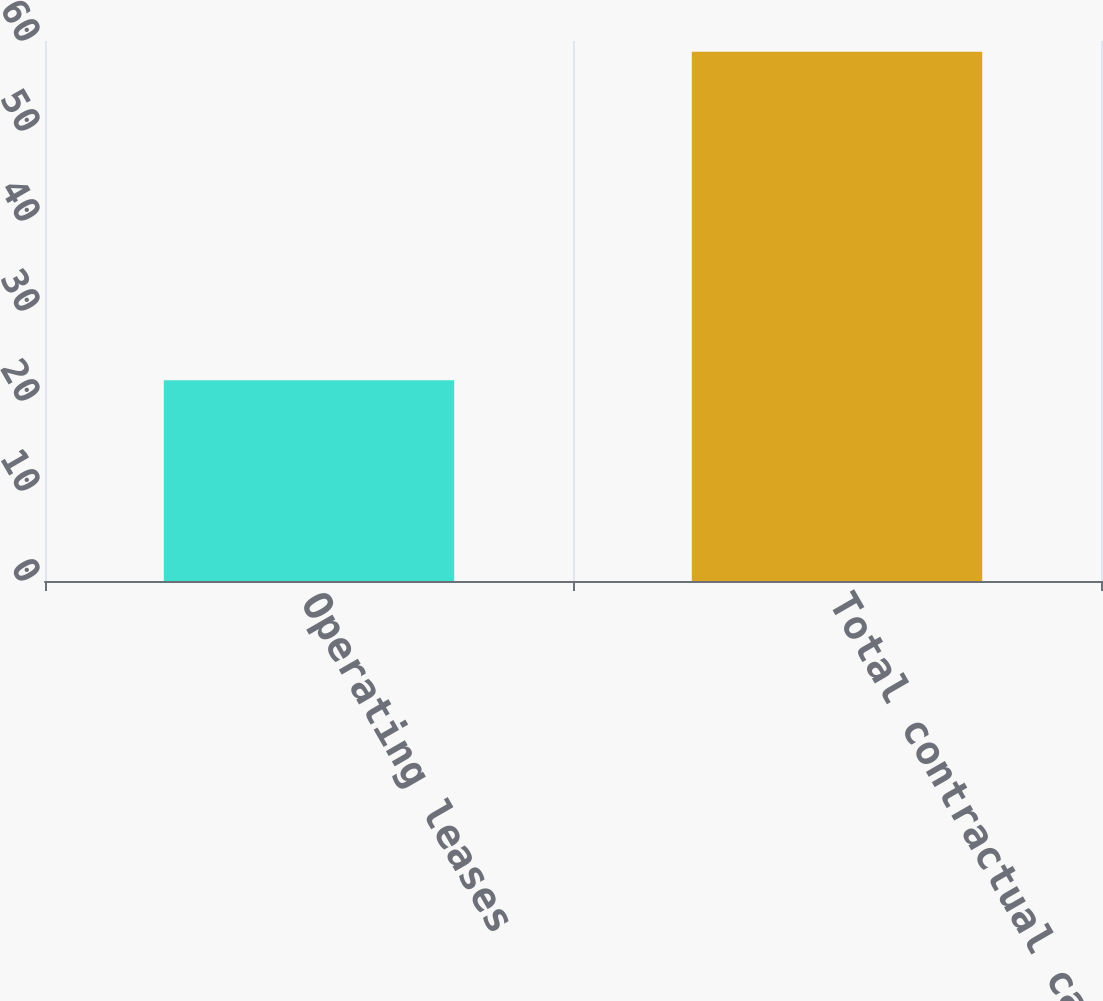<chart> <loc_0><loc_0><loc_500><loc_500><bar_chart><fcel>Operating leases<fcel>Total contractual cash<nl><fcel>22.3<fcel>58.8<nl></chart> 